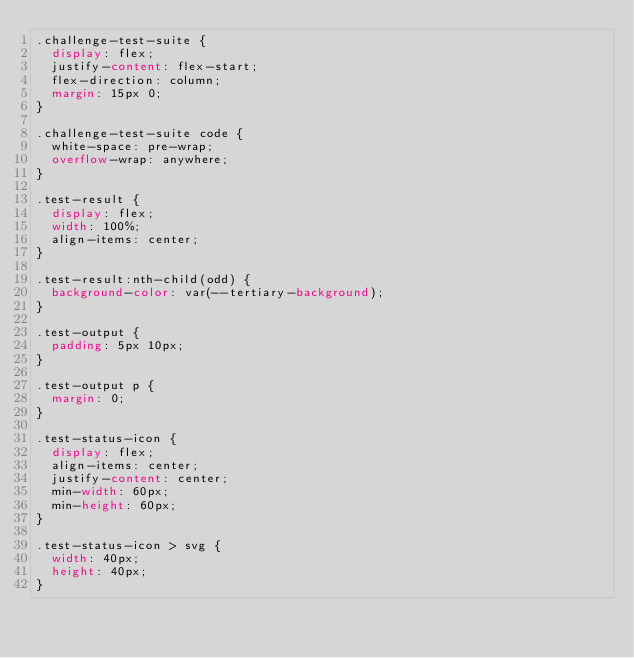Convert code to text. <code><loc_0><loc_0><loc_500><loc_500><_CSS_>.challenge-test-suite {
  display: flex;
  justify-content: flex-start;
  flex-direction: column;
  margin: 15px 0;
}

.challenge-test-suite code {
  white-space: pre-wrap;
  overflow-wrap: anywhere;
}

.test-result {
  display: flex;
  width: 100%;
  align-items: center;
}

.test-result:nth-child(odd) {
  background-color: var(--tertiary-background);
}

.test-output {
  padding: 5px 10px;
}

.test-output p {
  margin: 0;
}

.test-status-icon {
  display: flex;
  align-items: center;
  justify-content: center;
  min-width: 60px;
  min-height: 60px;
}

.test-status-icon > svg {
  width: 40px;
  height: 40px;
}
</code> 